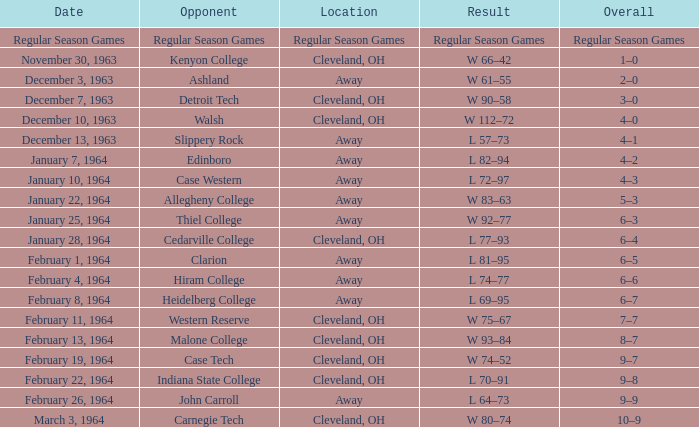What is the Location with a Date that is december 10, 1963? Cleveland, OH. 